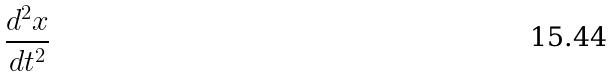<formula> <loc_0><loc_0><loc_500><loc_500>\frac { d ^ { 2 } x } { d t ^ { 2 } }</formula> 